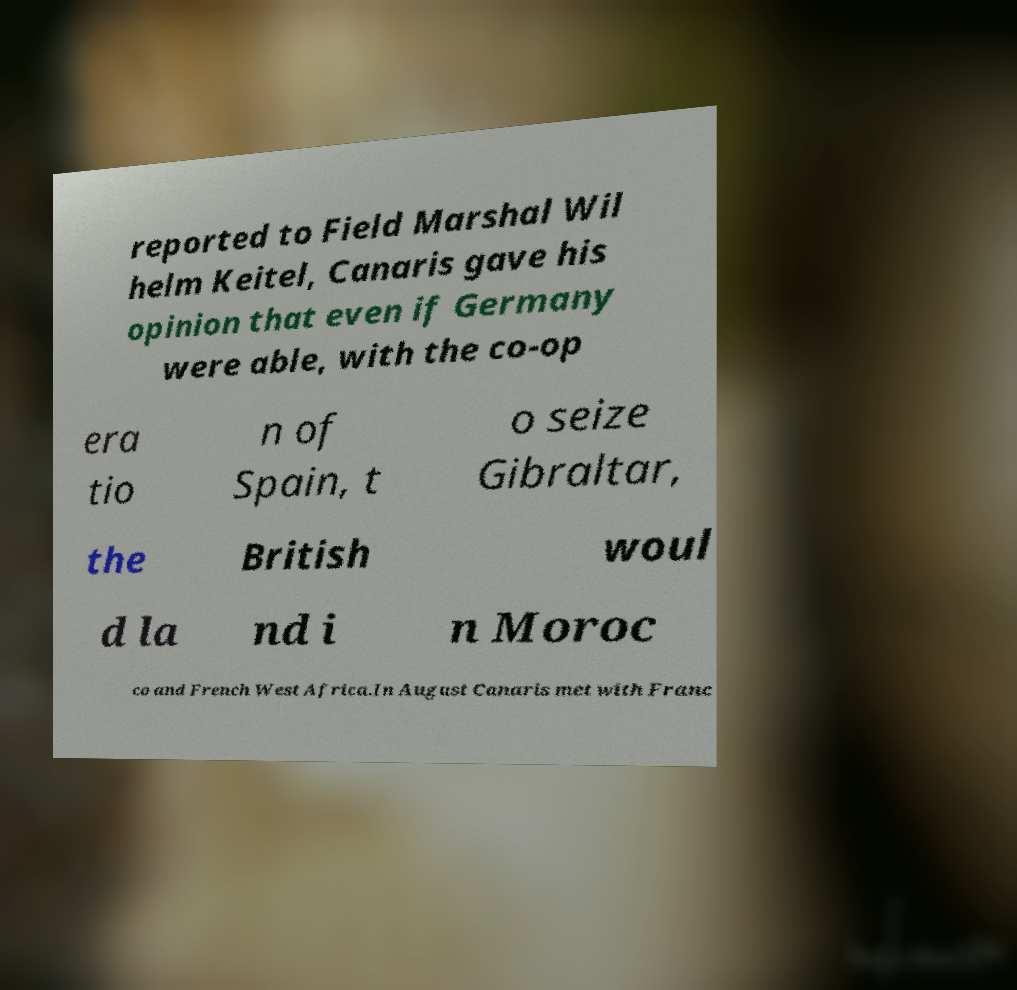Could you assist in decoding the text presented in this image and type it out clearly? reported to Field Marshal Wil helm Keitel, Canaris gave his opinion that even if Germany were able, with the co-op era tio n of Spain, t o seize Gibraltar, the British woul d la nd i n Moroc co and French West Africa.In August Canaris met with Franc 